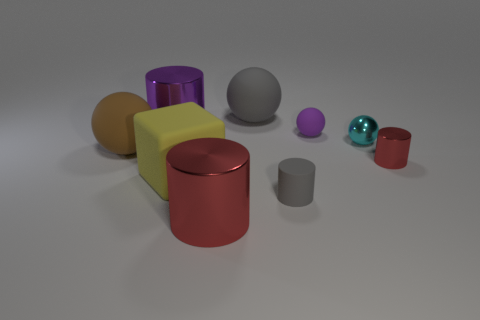Is the size of the gray sphere the same as the purple metal cylinder? Upon observing the image, it appears that the size of the gray sphere is not identical to the purple metal cylinder. The gray sphere is smaller in diameter compared to the height of the purple cylinder, which suggests a difference in volume as well. 